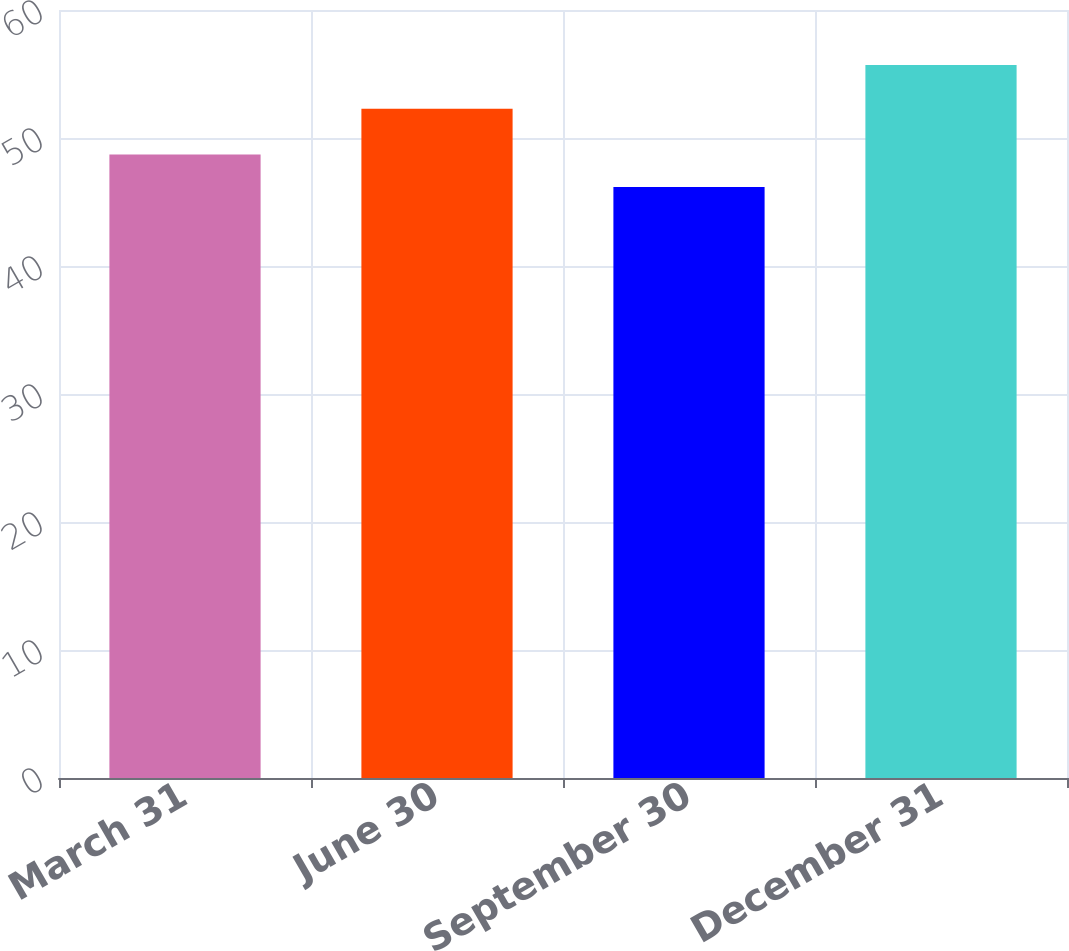Convert chart. <chart><loc_0><loc_0><loc_500><loc_500><bar_chart><fcel>March 31<fcel>June 30<fcel>September 30<fcel>December 31<nl><fcel>48.71<fcel>52.28<fcel>46.17<fcel>55.7<nl></chart> 